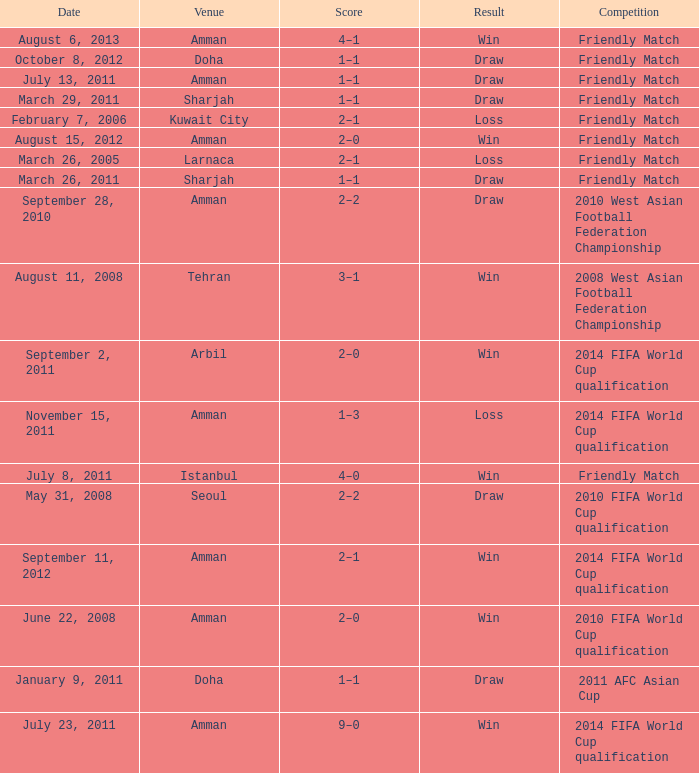What was the name of the competition that took place on may 31, 2008? 2010 FIFA World Cup qualification. 